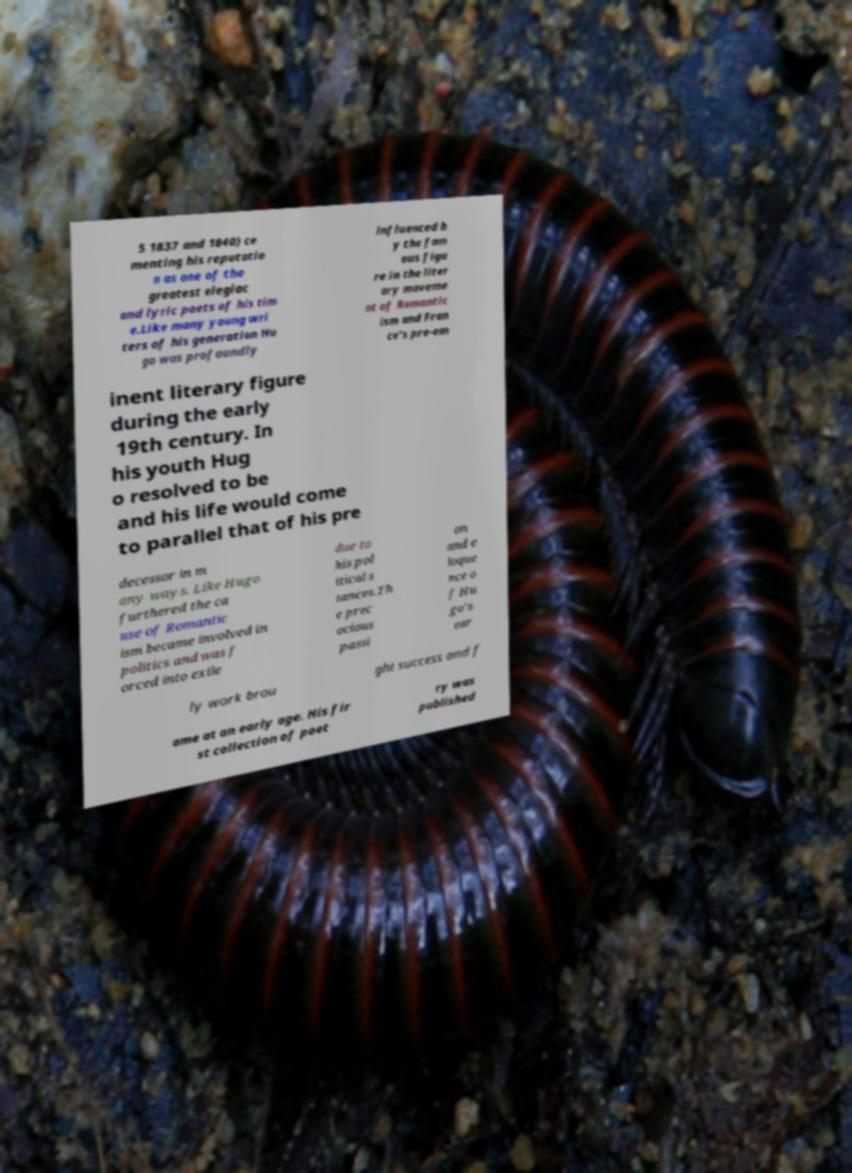Can you read and provide the text displayed in the image?This photo seems to have some interesting text. Can you extract and type it out for me? 5 1837 and 1840) ce menting his reputatio n as one of the greatest elegiac and lyric poets of his tim e.Like many young wri ters of his generation Hu go was profoundly influenced b y the fam ous figu re in the liter ary moveme nt of Romantic ism and Fran ce's pre-em inent literary figure during the early 19th century. In his youth Hug o resolved to be and his life would come to parallel that of his pre decessor in m any ways. Like Hugo furthered the ca use of Romantic ism became involved in politics and was f orced into exile due to his pol itical s tances.Th e prec ocious passi on and e loque nce o f Hu go's ear ly work brou ght success and f ame at an early age. His fir st collection of poet ry was published 